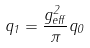Convert formula to latex. <formula><loc_0><loc_0><loc_500><loc_500>q _ { 1 } = \frac { g _ { e f f } ^ { 2 } } { \pi } q _ { 0 }</formula> 